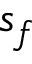<formula> <loc_0><loc_0><loc_500><loc_500>s _ { f }</formula> 